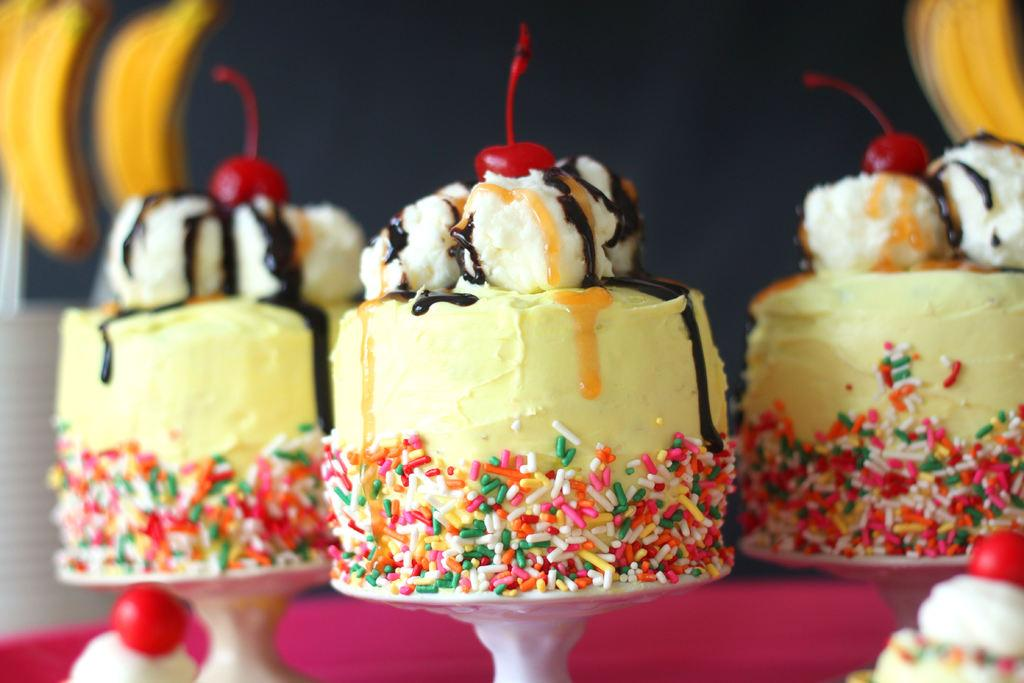What type of food items are present in the image? There are cakes, cherries, and bananas in the image. Can you describe the background of the image? The background of the image is blurred. What type of pollution can be seen in the image? There is no pollution present in the image. How many clovers are visible in the image? There are no clovers present in the image. 